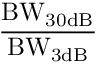Convert formula to latex. <formula><loc_0><loc_0><loc_500><loc_500>\frac { B W _ { 3 0 d B } } { B W _ { 3 d B } }</formula> 